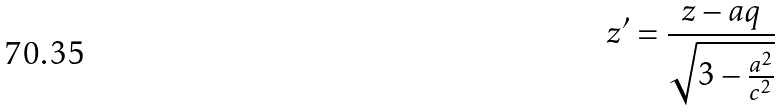Convert formula to latex. <formula><loc_0><loc_0><loc_500><loc_500>z ^ { \prime } = \frac { z - a q } { \sqrt { 3 - \frac { a ^ { 2 } } { c ^ { 2 } } } }</formula> 